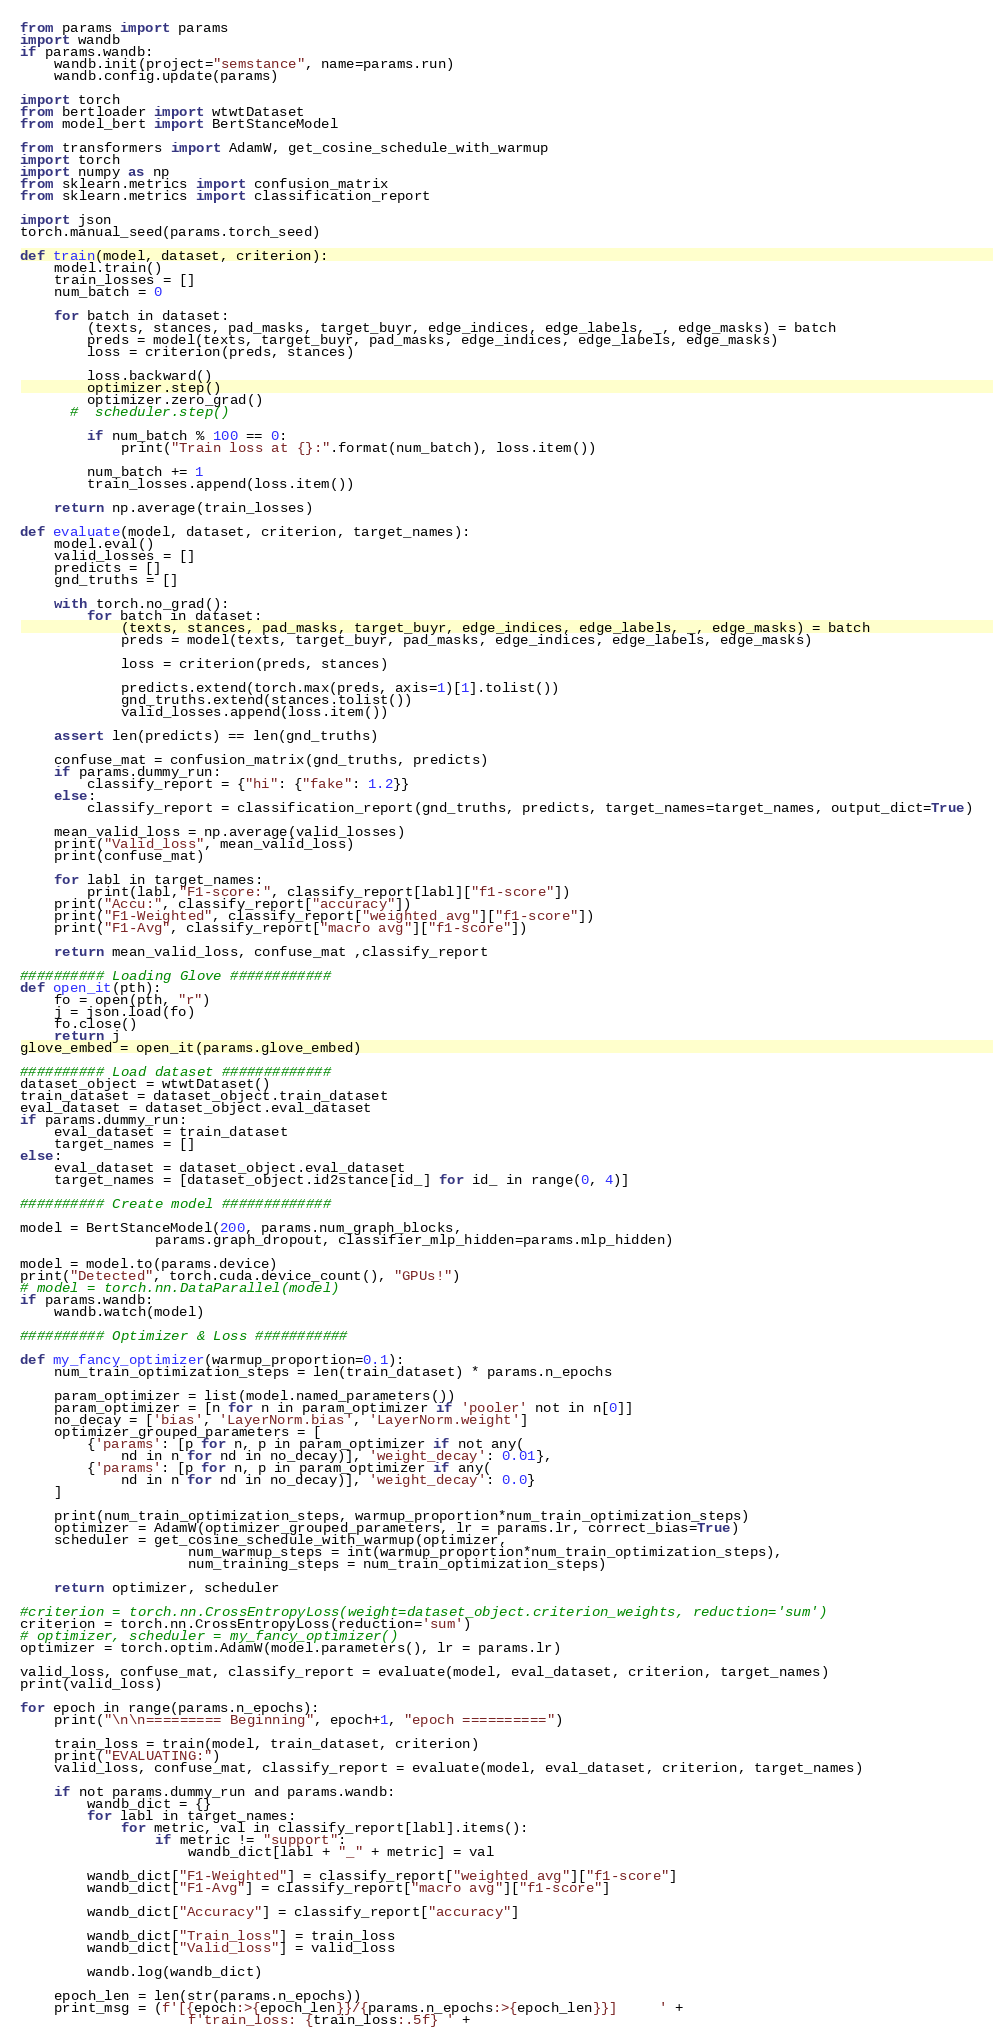<code> <loc_0><loc_0><loc_500><loc_500><_Python_>from params import params
import wandb
if params.wandb:
    wandb.init(project="semstance", name=params.run)
    wandb.config.update(params)

import torch
from bertloader import wtwtDataset
from model_bert import BertStanceModel

from transformers import AdamW, get_cosine_schedule_with_warmup
import torch
import numpy as np
from sklearn.metrics import confusion_matrix
from sklearn.metrics import classification_report

import json
torch.manual_seed(params.torch_seed)

def train(model, dataset, criterion):
    model.train()
    train_losses = []
    num_batch = 0

    for batch in dataset:
        (texts, stances, pad_masks, target_buyr, edge_indices, edge_labels, _, edge_masks) = batch
        preds = model(texts, target_buyr, pad_masks, edge_indices, edge_labels, edge_masks)
        loss = criterion(preds, stances)

        loss.backward()
        optimizer.step()
        optimizer.zero_grad()
      #  scheduler.step()

        if num_batch % 100 == 0:
            print("Train loss at {}:".format(num_batch), loss.item())

        num_batch += 1
        train_losses.append(loss.item())

    return np.average(train_losses)

def evaluate(model, dataset, criterion, target_names):
    model.eval()
    valid_losses = []
    predicts = []
    gnd_truths = []

    with torch.no_grad():
        for batch in dataset:
            (texts, stances, pad_masks, target_buyr, edge_indices, edge_labels, _, edge_masks) = batch
            preds = model(texts, target_buyr, pad_masks, edge_indices, edge_labels, edge_masks)

            loss = criterion(preds, stances)

            predicts.extend(torch.max(preds, axis=1)[1].tolist())
            gnd_truths.extend(stances.tolist())
            valid_losses.append(loss.item())

    assert len(predicts) == len(gnd_truths)

    confuse_mat = confusion_matrix(gnd_truths, predicts)
    if params.dummy_run:
        classify_report = {"hi": {"fake": 1.2}}
    else:
        classify_report = classification_report(gnd_truths, predicts, target_names=target_names, output_dict=True)

    mean_valid_loss = np.average(valid_losses)
    print("Valid_loss", mean_valid_loss)
    print(confuse_mat)

    for labl in target_names:
        print(labl,"F1-score:", classify_report[labl]["f1-score"])
    print("Accu:", classify_report["accuracy"])
    print("F1-Weighted", classify_report["weighted avg"]["f1-score"])
    print("F1-Avg", classify_report["macro avg"]["f1-score"])

    return mean_valid_loss, confuse_mat ,classify_report

########## Loading Glove ############
def open_it(pth):
    fo = open(pth, "r")
    j = json.load(fo)
    fo.close()
    return j
glove_embed = open_it(params.glove_embed)

########## Load dataset #############
dataset_object = wtwtDataset()
train_dataset = dataset_object.train_dataset
eval_dataset = dataset_object.eval_dataset
if params.dummy_run:
    eval_dataset = train_dataset
    target_names = []
else:
    eval_dataset = dataset_object.eval_dataset
    target_names = [dataset_object.id2stance[id_] for id_ in range(0, 4)]

########## Create model #############

model = BertStanceModel(200, params.num_graph_blocks,
                params.graph_dropout, classifier_mlp_hidden=params.mlp_hidden)

model = model.to(params.device)
print("Detected", torch.cuda.device_count(), "GPUs!")
# model = torch.nn.DataParallel(model)
if params.wandb:
    wandb.watch(model)

########## Optimizer & Loss ###########

def my_fancy_optimizer(warmup_proportion=0.1):
    num_train_optimization_steps = len(train_dataset) * params.n_epochs

    param_optimizer = list(model.named_parameters())
    param_optimizer = [n for n in param_optimizer if 'pooler' not in n[0]]
    no_decay = ['bias', 'LayerNorm.bias', 'LayerNorm.weight']
    optimizer_grouped_parameters = [
        {'params': [p for n, p in param_optimizer if not any(
            nd in n for nd in no_decay)], 'weight_decay': 0.01},
        {'params': [p for n, p in param_optimizer if any(
            nd in n for nd in no_decay)], 'weight_decay': 0.0}
    ]

    print(num_train_optimization_steps, warmup_proportion*num_train_optimization_steps)
    optimizer = AdamW(optimizer_grouped_parameters, lr = params.lr, correct_bias=True)
    scheduler = get_cosine_schedule_with_warmup(optimizer,
                    num_warmup_steps = int(warmup_proportion*num_train_optimization_steps),
                    num_training_steps = num_train_optimization_steps)

    return optimizer, scheduler

#criterion = torch.nn.CrossEntropyLoss(weight=dataset_object.criterion_weights, reduction='sum')
criterion = torch.nn.CrossEntropyLoss(reduction='sum')
# optimizer, scheduler = my_fancy_optimizer()
optimizer = torch.optim.AdamW(model.parameters(), lr = params.lr)

valid_loss, confuse_mat, classify_report = evaluate(model, eval_dataset, criterion, target_names)
print(valid_loss)

for epoch in range(params.n_epochs):
    print("\n\n========= Beginning", epoch+1, "epoch ==========")

    train_loss = train(model, train_dataset, criterion)
    print("EVALUATING:")
    valid_loss, confuse_mat, classify_report = evaluate(model, eval_dataset, criterion, target_names)

    if not params.dummy_run and params.wandb:
        wandb_dict = {}
        for labl in target_names:
            for metric, val in classify_report[labl].items():
                if metric != "support":
                    wandb_dict[labl + "_" + metric] = val

        wandb_dict["F1-Weighted"] = classify_report["weighted avg"]["f1-score"]
        wandb_dict["F1-Avg"] = classify_report["macro avg"]["f1-score"]

        wandb_dict["Accuracy"] = classify_report["accuracy"]

        wandb_dict["Train_loss"] = train_loss
        wandb_dict["Valid_loss"] = valid_loss

        wandb.log(wandb_dict)

    epoch_len = len(str(params.n_epochs))
    print_msg = (f'[{epoch:>{epoch_len}}/{params.n_epochs:>{epoch_len}}]     ' +
                    f'train_loss: {train_loss:.5f} ' +</code> 